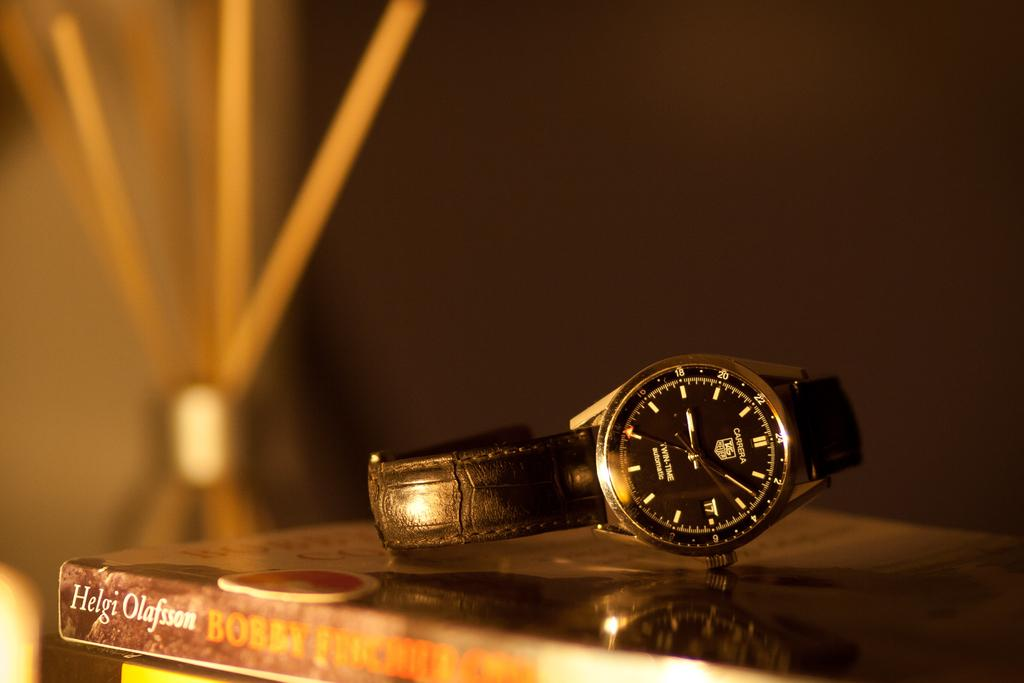<image>
Give a short and clear explanation of the subsequent image. A Carberra watch on a book written by Heidi Olafsson. 